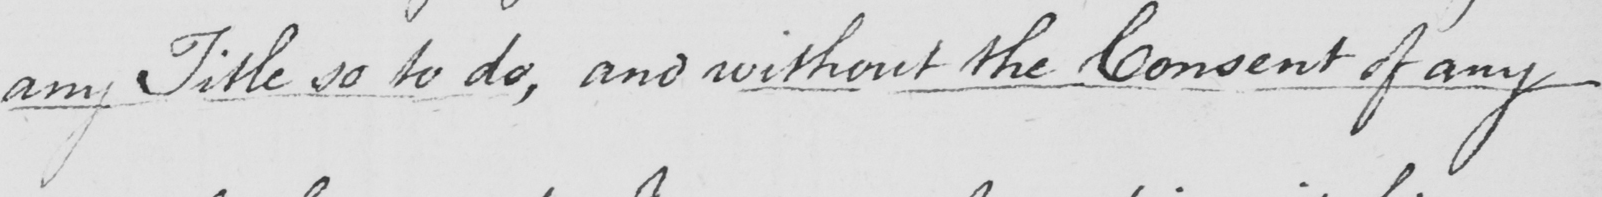Can you tell me what this handwritten text says? any Title so to do ,  and without the Consent of any 